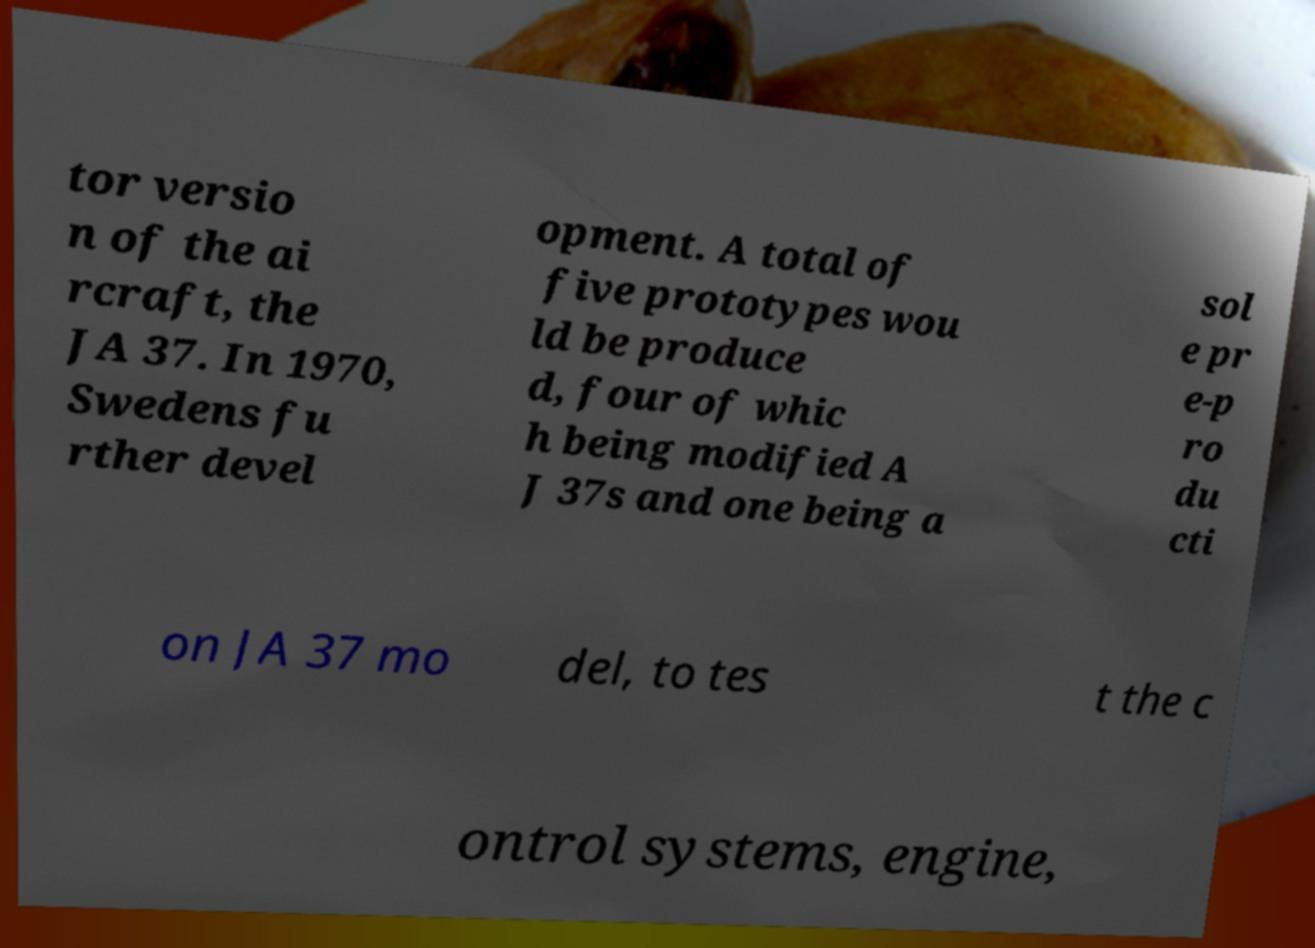Can you read and provide the text displayed in the image?This photo seems to have some interesting text. Can you extract and type it out for me? tor versio n of the ai rcraft, the JA 37. In 1970, Swedens fu rther devel opment. A total of five prototypes wou ld be produce d, four of whic h being modified A J 37s and one being a sol e pr e-p ro du cti on JA 37 mo del, to tes t the c ontrol systems, engine, 